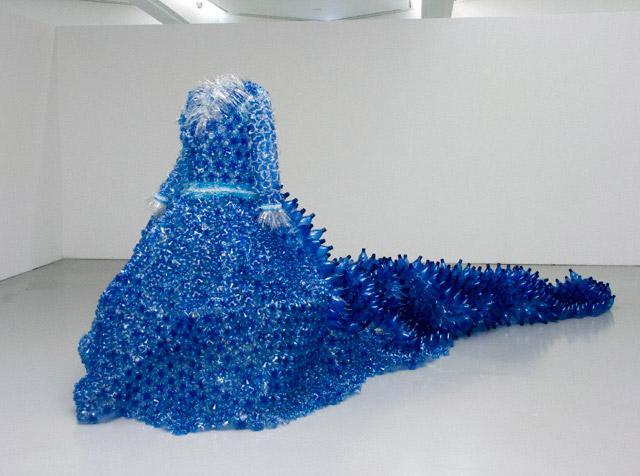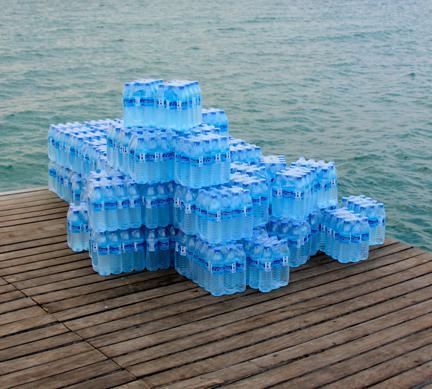The first image is the image on the left, the second image is the image on the right. Considering the images on both sides, is "An image shows bottles with orange lids." valid? Answer yes or no. No. 